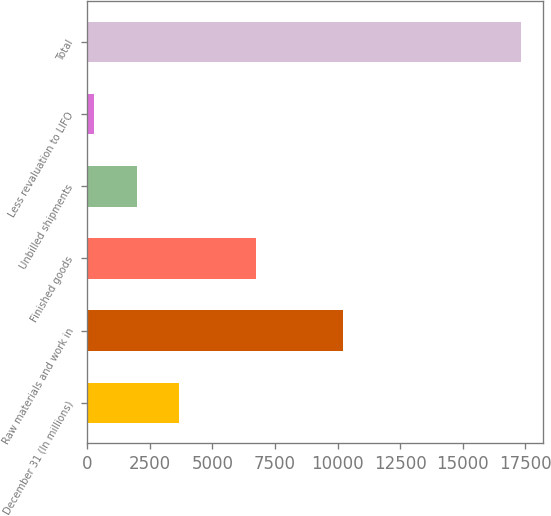Convert chart. <chart><loc_0><loc_0><loc_500><loc_500><bar_chart><fcel>December 31 (In millions)<fcel>Raw materials and work in<fcel>Finished goods<fcel>Unbilled shipments<fcel>Less revaluation to LIFO<fcel>Total<nl><fcel>3683.4<fcel>10220<fcel>6726<fcel>1978.2<fcel>273<fcel>17325<nl></chart> 